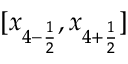<formula> <loc_0><loc_0><loc_500><loc_500>[ x _ { 4 - \frac { 1 } { 2 } } , x _ { 4 + \frac { 1 } { 2 } } ]</formula> 